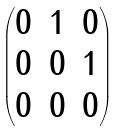<formula> <loc_0><loc_0><loc_500><loc_500>\begin{pmatrix} 0 & 1 & 0 \\ 0 & 0 & 1 \\ 0 & 0 & 0 \\ \end{pmatrix}</formula> 